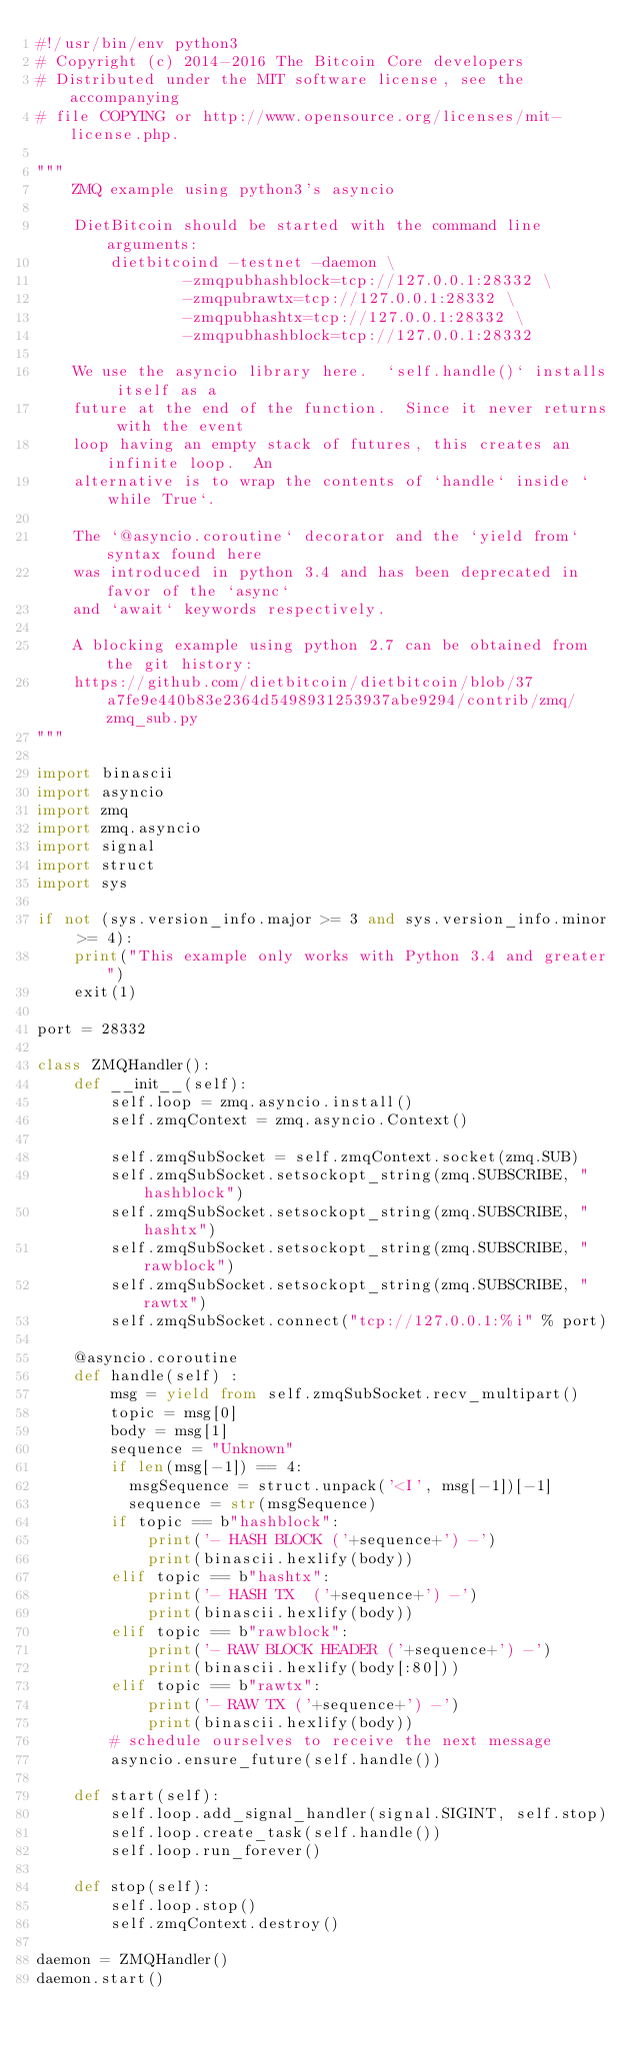Convert code to text. <code><loc_0><loc_0><loc_500><loc_500><_Python_>#!/usr/bin/env python3
# Copyright (c) 2014-2016 The Bitcoin Core developers
# Distributed under the MIT software license, see the accompanying
# file COPYING or http://www.opensource.org/licenses/mit-license.php.

"""
    ZMQ example using python3's asyncio

    DietBitcoin should be started with the command line arguments:
        dietbitcoind -testnet -daemon \
                -zmqpubhashblock=tcp://127.0.0.1:28332 \
                -zmqpubrawtx=tcp://127.0.0.1:28332 \
                -zmqpubhashtx=tcp://127.0.0.1:28332 \
                -zmqpubhashblock=tcp://127.0.0.1:28332

    We use the asyncio library here.  `self.handle()` installs itself as a
    future at the end of the function.  Since it never returns with the event
    loop having an empty stack of futures, this creates an infinite loop.  An
    alternative is to wrap the contents of `handle` inside `while True`.

    The `@asyncio.coroutine` decorator and the `yield from` syntax found here
    was introduced in python 3.4 and has been deprecated in favor of the `async`
    and `await` keywords respectively.

    A blocking example using python 2.7 can be obtained from the git history:
    https://github.com/dietbitcoin/dietbitcoin/blob/37a7fe9e440b83e2364d5498931253937abe9294/contrib/zmq/zmq_sub.py
"""

import binascii
import asyncio
import zmq
import zmq.asyncio
import signal
import struct
import sys

if not (sys.version_info.major >= 3 and sys.version_info.minor >= 4):
    print("This example only works with Python 3.4 and greater")
    exit(1)

port = 28332

class ZMQHandler():
    def __init__(self):
        self.loop = zmq.asyncio.install()
        self.zmqContext = zmq.asyncio.Context()

        self.zmqSubSocket = self.zmqContext.socket(zmq.SUB)
        self.zmqSubSocket.setsockopt_string(zmq.SUBSCRIBE, "hashblock")
        self.zmqSubSocket.setsockopt_string(zmq.SUBSCRIBE, "hashtx")
        self.zmqSubSocket.setsockopt_string(zmq.SUBSCRIBE, "rawblock")
        self.zmqSubSocket.setsockopt_string(zmq.SUBSCRIBE, "rawtx")
        self.zmqSubSocket.connect("tcp://127.0.0.1:%i" % port)

    @asyncio.coroutine
    def handle(self) :
        msg = yield from self.zmqSubSocket.recv_multipart()
        topic = msg[0]
        body = msg[1]
        sequence = "Unknown"
        if len(msg[-1]) == 4:
          msgSequence = struct.unpack('<I', msg[-1])[-1]
          sequence = str(msgSequence)
        if topic == b"hashblock":
            print('- HASH BLOCK ('+sequence+') -')
            print(binascii.hexlify(body))
        elif topic == b"hashtx":
            print('- HASH TX  ('+sequence+') -')
            print(binascii.hexlify(body))
        elif topic == b"rawblock":
            print('- RAW BLOCK HEADER ('+sequence+') -')
            print(binascii.hexlify(body[:80]))
        elif topic == b"rawtx":
            print('- RAW TX ('+sequence+') -')
            print(binascii.hexlify(body))
        # schedule ourselves to receive the next message
        asyncio.ensure_future(self.handle())

    def start(self):
        self.loop.add_signal_handler(signal.SIGINT, self.stop)
        self.loop.create_task(self.handle())
        self.loop.run_forever()

    def stop(self):
        self.loop.stop()
        self.zmqContext.destroy()

daemon = ZMQHandler()
daemon.start()
</code> 